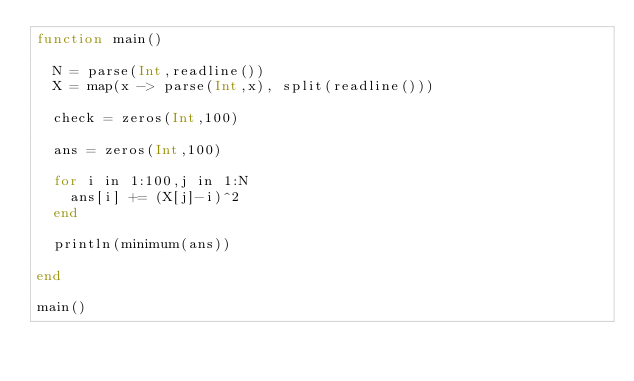<code> <loc_0><loc_0><loc_500><loc_500><_Julia_>function main()
  
  N = parse(Int,readline())
  X = map(x -> parse(Int,x), split(readline()))
  
  check = zeros(Int,100)
  
  ans = zeros(Int,100)
  
  for i in 1:100,j in 1:N
    ans[i] += (X[j]-i)^2
  end
  
  println(minimum(ans))
  
end

main()</code> 